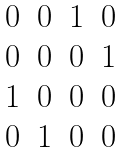Convert formula to latex. <formula><loc_0><loc_0><loc_500><loc_500>\begin{matrix} 0 & 0 & 1 & 0 \\ 0 & 0 & 0 & 1 \\ 1 & 0 & 0 & 0 \\ 0 & 1 & 0 & 0 \\ \end{matrix}</formula> 